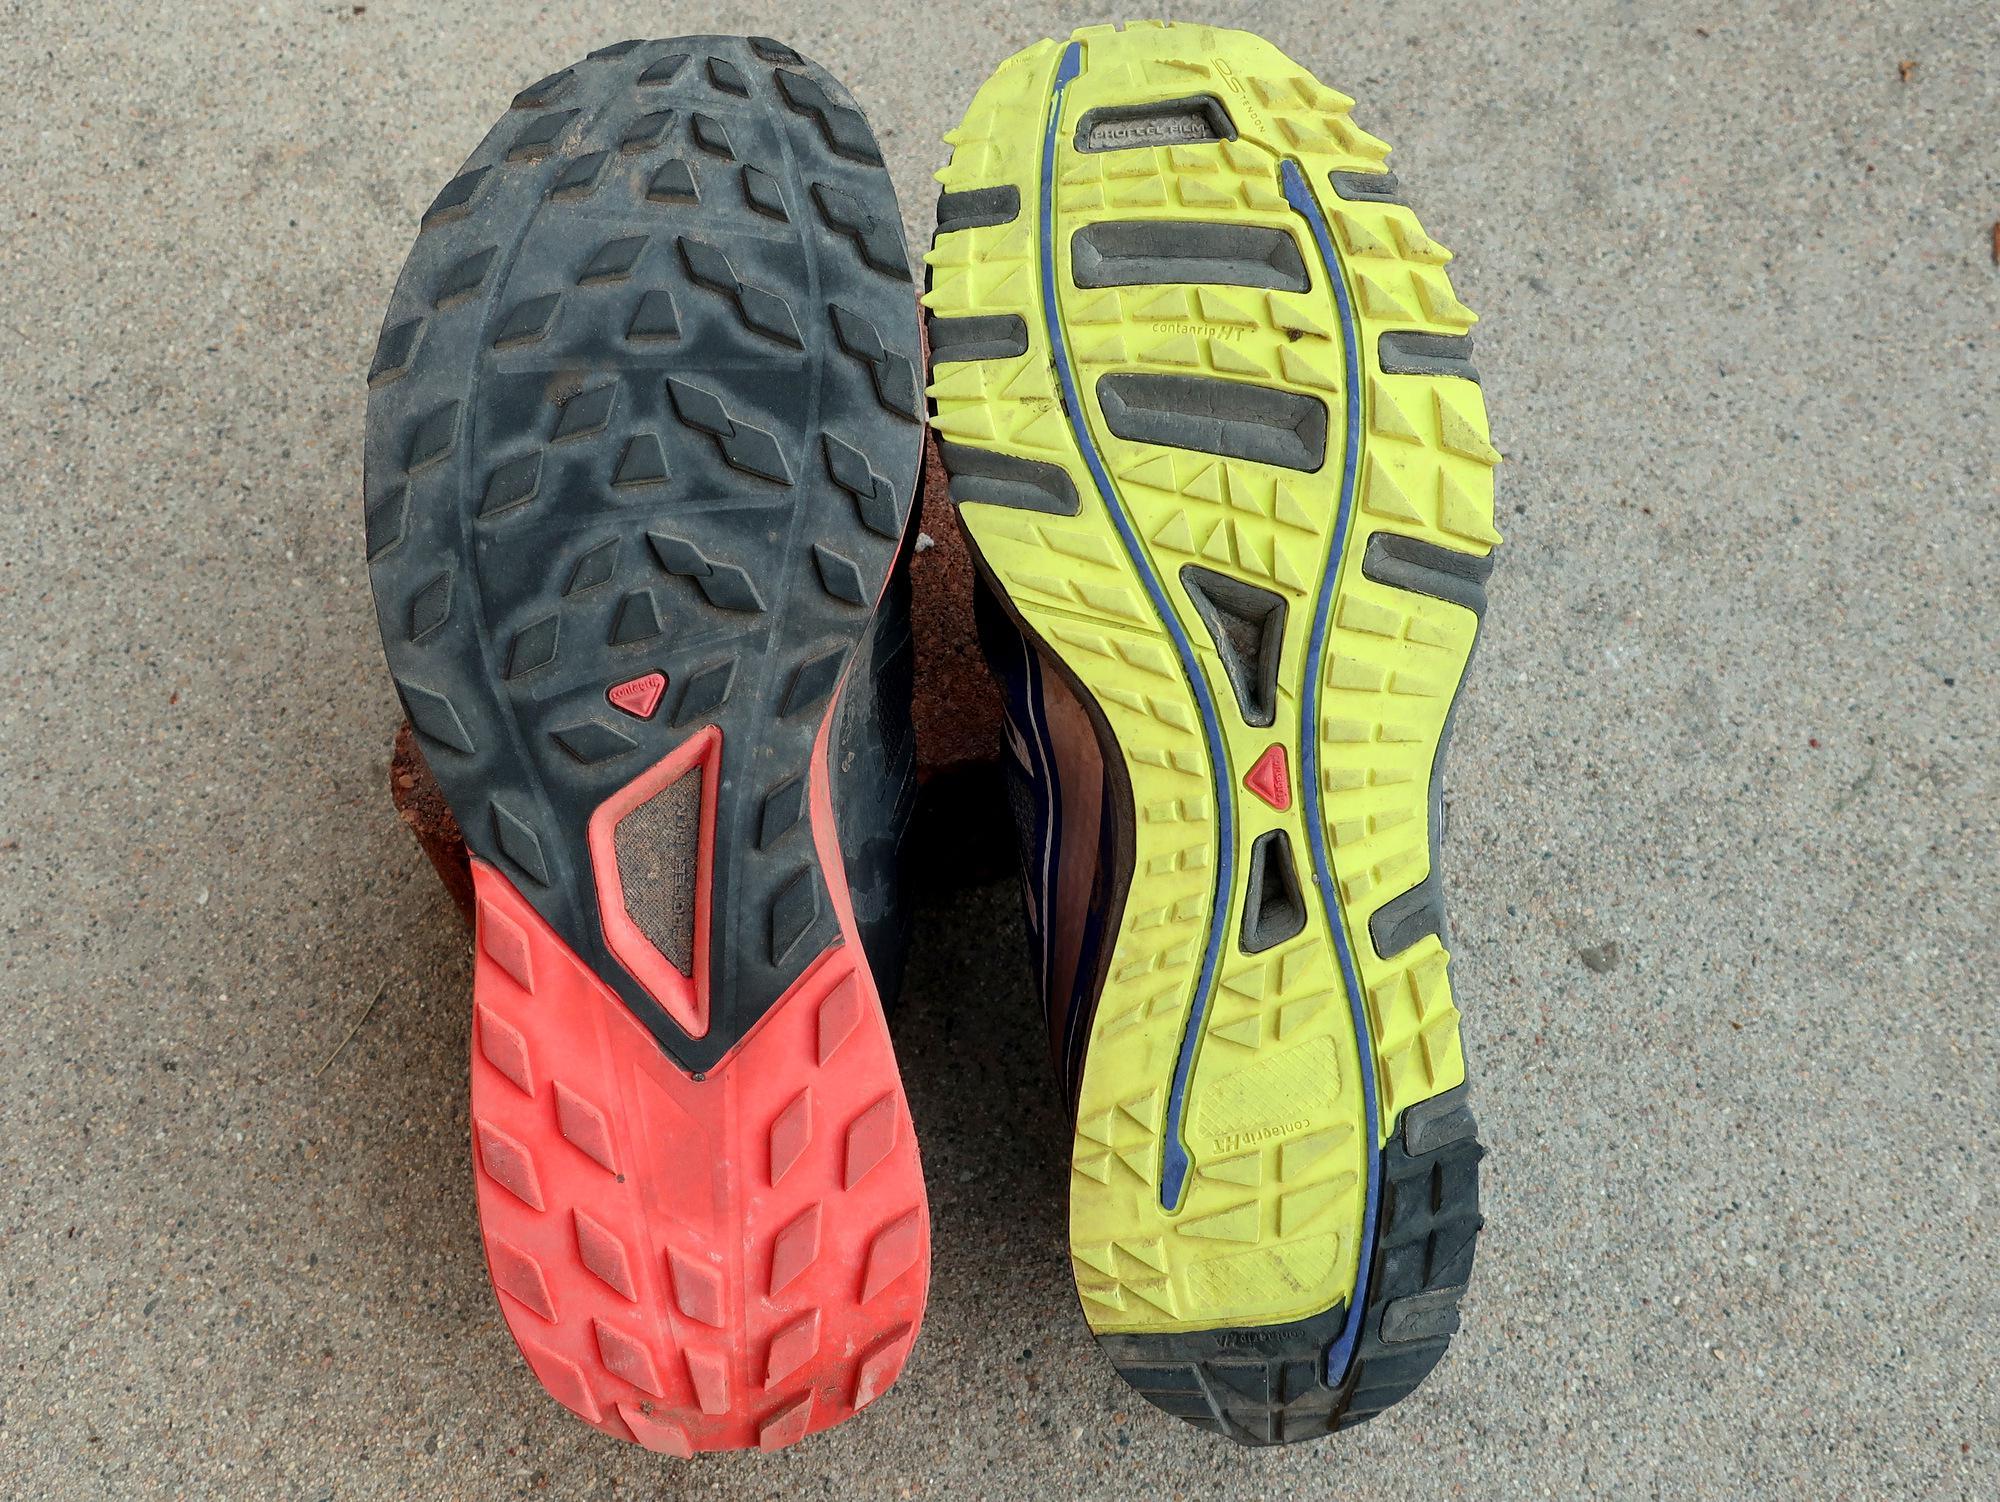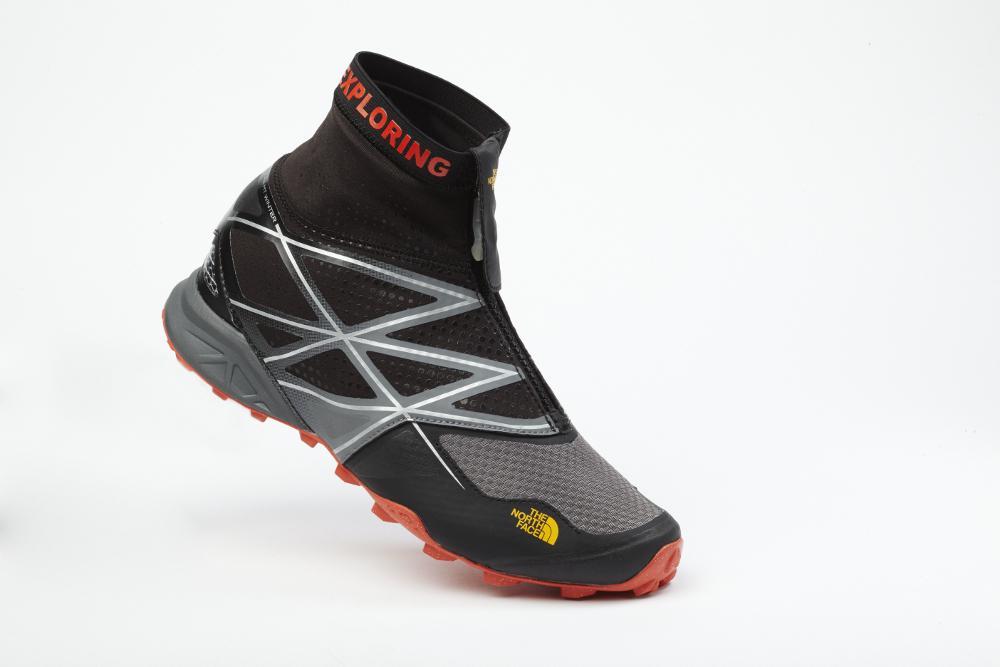The first image is the image on the left, the second image is the image on the right. Assess this claim about the two images: "There is a running show with a yellow sole facing up.". Correct or not? Answer yes or no. Yes. 